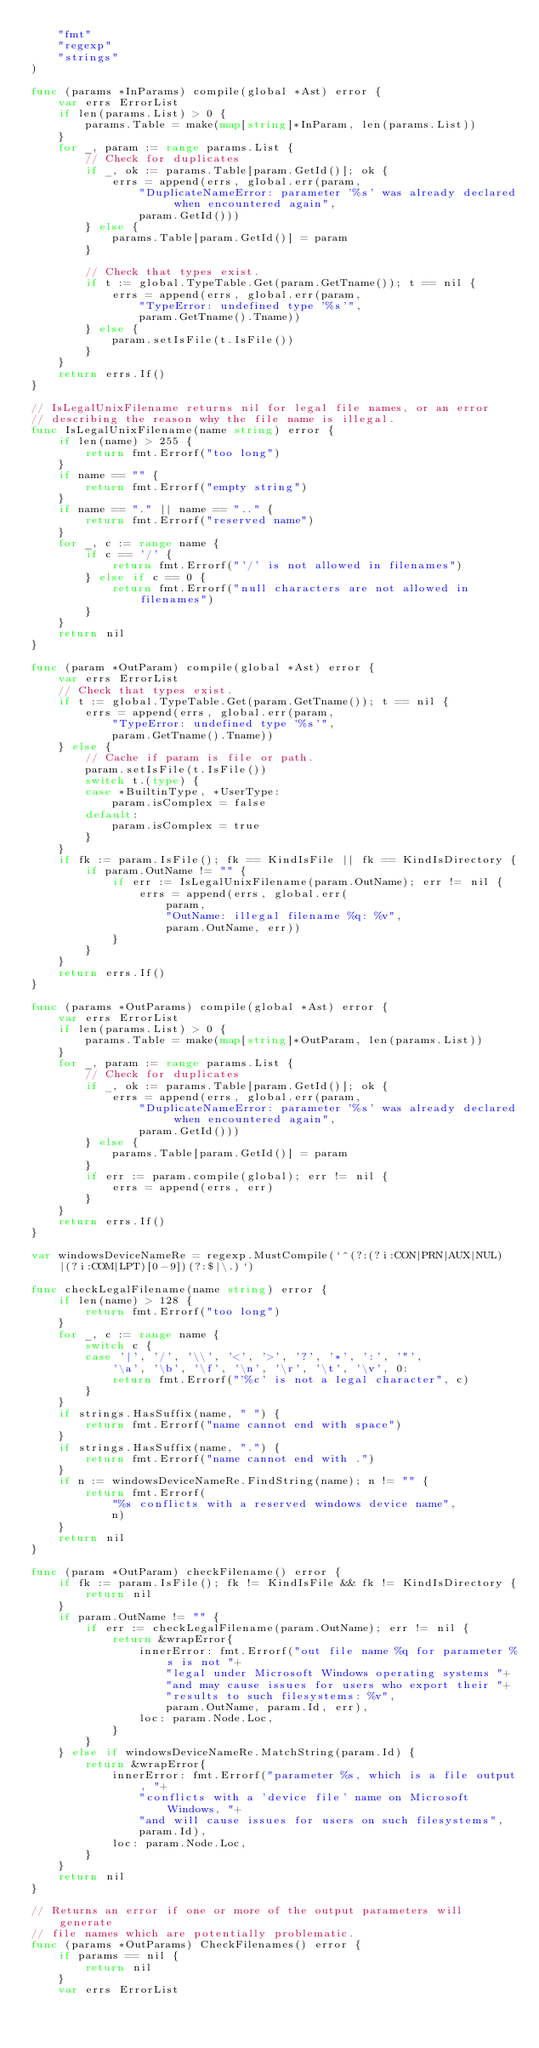Convert code to text. <code><loc_0><loc_0><loc_500><loc_500><_Go_>	"fmt"
	"regexp"
	"strings"
)

func (params *InParams) compile(global *Ast) error {
	var errs ErrorList
	if len(params.List) > 0 {
		params.Table = make(map[string]*InParam, len(params.List))
	}
	for _, param := range params.List {
		// Check for duplicates
		if _, ok := params.Table[param.GetId()]; ok {
			errs = append(errs, global.err(param,
				"DuplicateNameError: parameter '%s' was already declared when encountered again",
				param.GetId()))
		} else {
			params.Table[param.GetId()] = param
		}

		// Check that types exist.
		if t := global.TypeTable.Get(param.GetTname()); t == nil {
			errs = append(errs, global.err(param,
				"TypeError: undefined type '%s'",
				param.GetTname().Tname))
		} else {
			param.setIsFile(t.IsFile())
		}
	}
	return errs.If()
}

// IsLegalUnixFilename returns nil for legal file names, or an error
// describing the reason why the file name is illegal.
func IsLegalUnixFilename(name string) error {
	if len(name) > 255 {
		return fmt.Errorf("too long")
	}
	if name == "" {
		return fmt.Errorf("empty string")
	}
	if name == "." || name == ".." {
		return fmt.Errorf("reserved name")
	}
	for _, c := range name {
		if c == '/' {
			return fmt.Errorf("'/' is not allowed in filenames")
		} else if c == 0 {
			return fmt.Errorf("null characters are not allowed in filenames")
		}
	}
	return nil
}

func (param *OutParam) compile(global *Ast) error {
	var errs ErrorList
	// Check that types exist.
	if t := global.TypeTable.Get(param.GetTname()); t == nil {
		errs = append(errs, global.err(param,
			"TypeError: undefined type '%s'",
			param.GetTname().Tname))
	} else {
		// Cache if param is file or path.
		param.setIsFile(t.IsFile())
		switch t.(type) {
		case *BuiltinType, *UserType:
			param.isComplex = false
		default:
			param.isComplex = true
		}
	}
	if fk := param.IsFile(); fk == KindIsFile || fk == KindIsDirectory {
		if param.OutName != "" {
			if err := IsLegalUnixFilename(param.OutName); err != nil {
				errs = append(errs, global.err(
					param,
					"OutName: illegal filename %q: %v",
					param.OutName, err))
			}
		}
	}
	return errs.If()
}

func (params *OutParams) compile(global *Ast) error {
	var errs ErrorList
	if len(params.List) > 0 {
		params.Table = make(map[string]*OutParam, len(params.List))
	}
	for _, param := range params.List {
		// Check for duplicates
		if _, ok := params.Table[param.GetId()]; ok {
			errs = append(errs, global.err(param,
				"DuplicateNameError: parameter '%s' was already declared when encountered again",
				param.GetId()))
		} else {
			params.Table[param.GetId()] = param
		}
		if err := param.compile(global); err != nil {
			errs = append(errs, err)
		}
	}
	return errs.If()
}

var windowsDeviceNameRe = regexp.MustCompile(`^(?:(?i:CON|PRN|AUX|NUL)|(?i:COM|LPT)[0-9])(?:$|\.)`)

func checkLegalFilename(name string) error {
	if len(name) > 128 {
		return fmt.Errorf("too long")
	}
	for _, c := range name {
		switch c {
		case '|', '/', '\\', '<', '>', '?', '*', ':', '"',
			'\a', '\b', '\f', '\n', '\r', '\t', '\v', 0:
			return fmt.Errorf("'%c' is not a legal character", c)
		}
	}
	if strings.HasSuffix(name, " ") {
		return fmt.Errorf("name cannot end with space")
	}
	if strings.HasSuffix(name, ".") {
		return fmt.Errorf("name cannot end with .")
	}
	if n := windowsDeviceNameRe.FindString(name); n != "" {
		return fmt.Errorf(
			"%s conflicts with a reserved windows device name",
			n)
	}
	return nil
}

func (param *OutParam) checkFilename() error {
	if fk := param.IsFile(); fk != KindIsFile && fk != KindIsDirectory {
		return nil
	}
	if param.OutName != "" {
		if err := checkLegalFilename(param.OutName); err != nil {
			return &wrapError{
				innerError: fmt.Errorf("out file name %q for parameter %s is not "+
					"legal under Microsoft Windows operating systems "+
					"and may cause issues for users who export their "+
					"results to such filesystems: %v",
					param.OutName, param.Id, err),
				loc: param.Node.Loc,
			}
		}
	} else if windowsDeviceNameRe.MatchString(param.Id) {
		return &wrapError{
			innerError: fmt.Errorf("parameter %s, which is a file output, "+
				"conflicts with a 'device file' name on Microsoft Windows, "+
				"and will cause issues for users on such filesystems",
				param.Id),
			loc: param.Node.Loc,
		}
	}
	return nil
}

// Returns an error if one or more of the output parameters will generate
// file names which are potentially problematic.
func (params *OutParams) CheckFilenames() error {
	if params == nil {
		return nil
	}
	var errs ErrorList</code> 